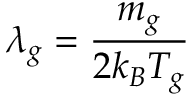<formula> <loc_0><loc_0><loc_500><loc_500>\lambda _ { g } = \frac { m _ { g } } { 2 k _ { B } T _ { g } }</formula> 